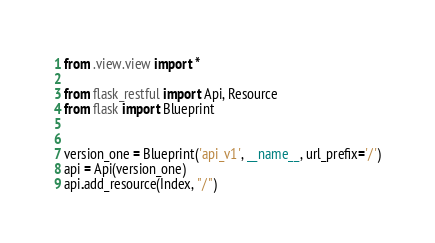Convert code to text. <code><loc_0><loc_0><loc_500><loc_500><_Python_>from .view.view import *

from flask_restful import Api, Resource
from flask import Blueprint


version_one = Blueprint('api_v1', __name__, url_prefix='/')
api = Api(version_one)
api.add_resource(Index, "/")</code> 